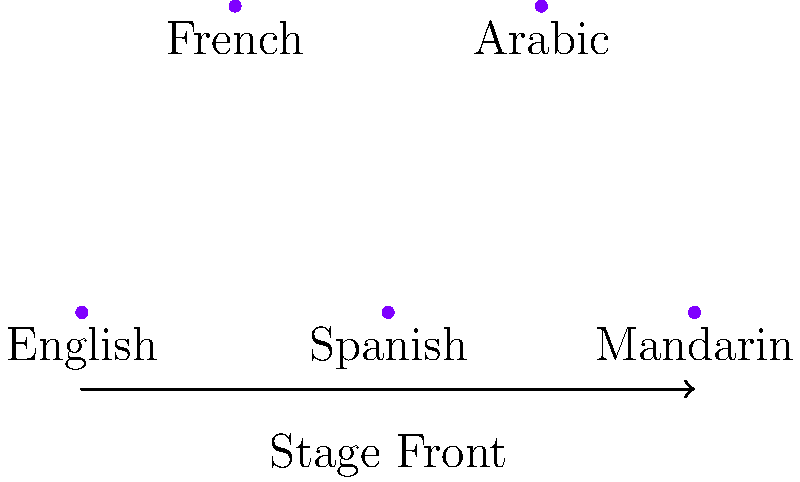In the given arrangement of speakers at a multilingual conference, which language representative is positioned centrally on the stage, potentially facilitating better interaction with both the audience and other speakers? To determine the centrally positioned speaker, we need to analyze the spatial arrangement:

1. The stage has two rows: a front row with three speakers and a back row with two speakers.
2. The front row contains English, Spanish, and Mandarin speakers (left to right).
3. The back row has French and Arabic speakers.
4. The central position would be in the middle of the stage, both horizontally and vertically.
5. Looking at the horizontal axis, the Spanish speaker is in the middle of the front row.
6. Vertically, the Spanish speaker is also in the front, which is closer to the audience.
7. The Spanish speaker's position allows easy interaction with other speakers on both sides and in the back row.
8. This central position also provides a good vantage point for audience engagement.

Therefore, the Spanish language representative is in the most central and advantageous position on the stage.
Answer: Spanish 